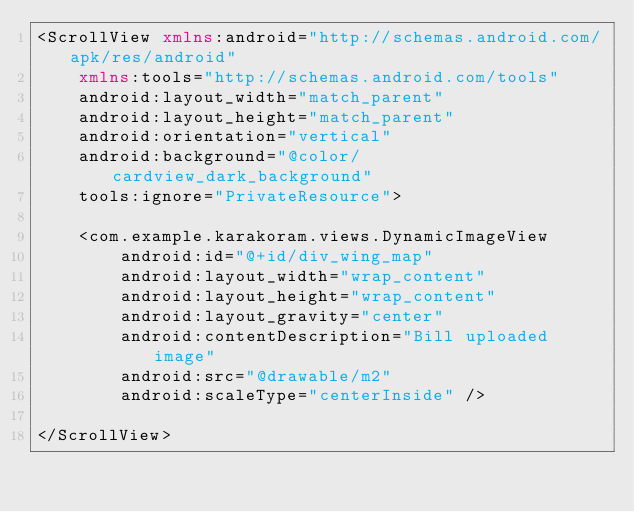Convert code to text. <code><loc_0><loc_0><loc_500><loc_500><_XML_><ScrollView xmlns:android="http://schemas.android.com/apk/res/android"
    xmlns:tools="http://schemas.android.com/tools"
    android:layout_width="match_parent"
    android:layout_height="match_parent"
    android:orientation="vertical"
    android:background="@color/cardview_dark_background"
    tools:ignore="PrivateResource">

    <com.example.karakoram.views.DynamicImageView
        android:id="@+id/div_wing_map"
        android:layout_width="wrap_content"
        android:layout_height="wrap_content"
        android:layout_gravity="center"
        android:contentDescription="Bill uploaded image"
        android:src="@drawable/m2"
        android:scaleType="centerInside" />

</ScrollView></code> 